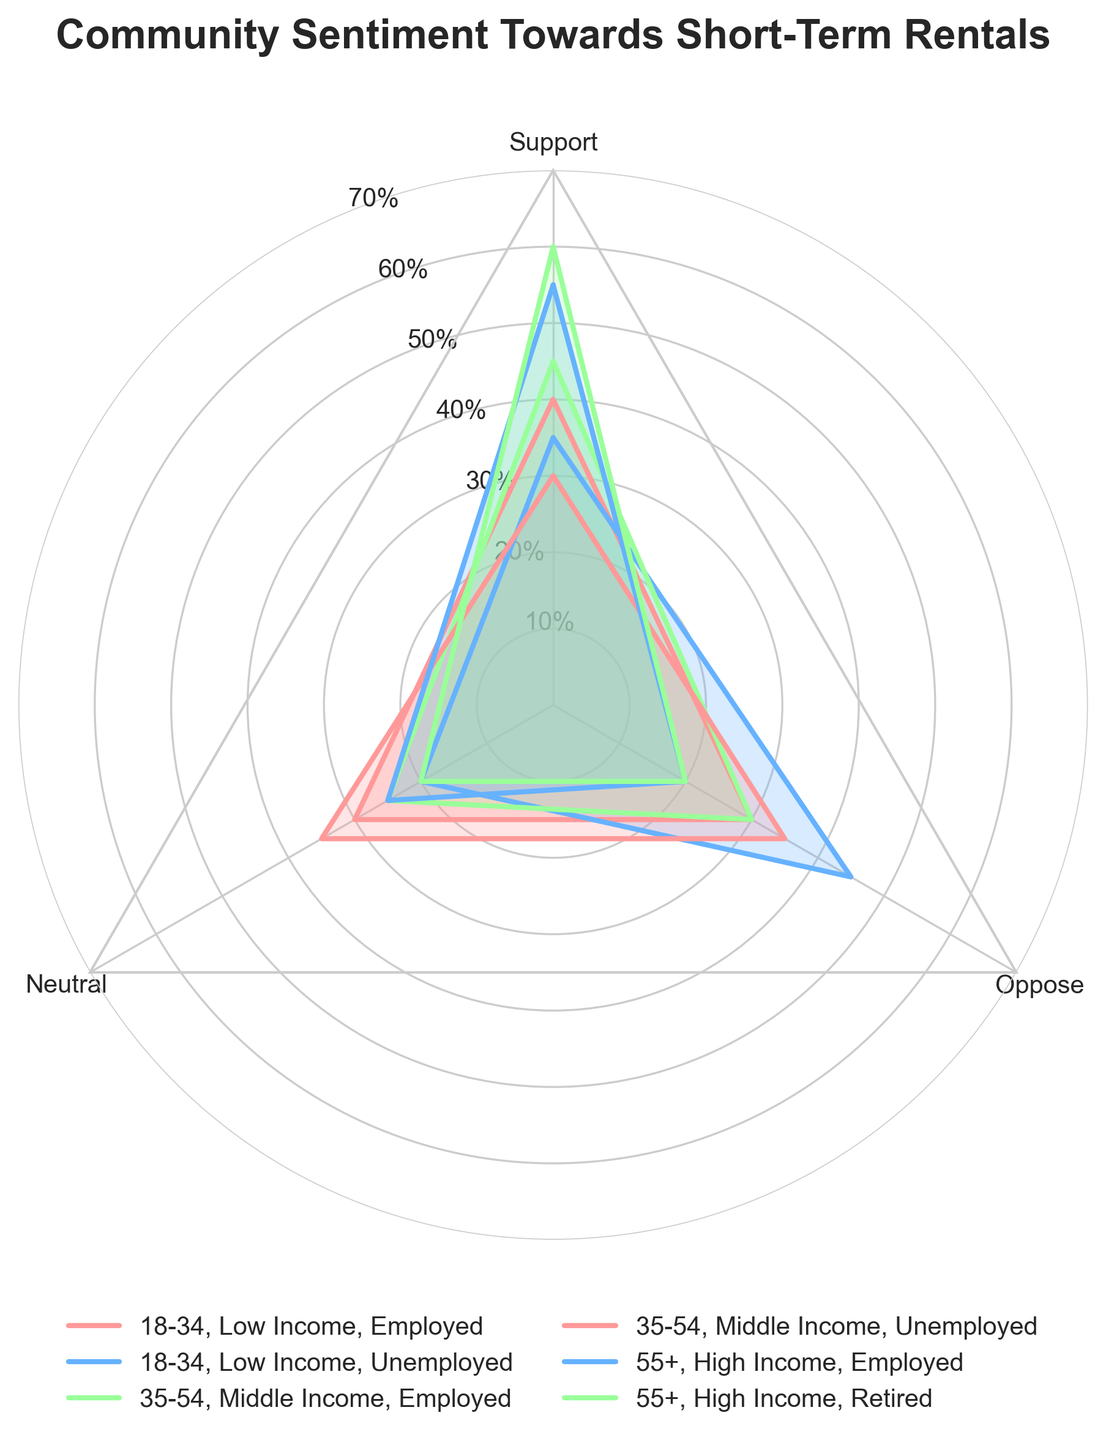What is the percentage of support for short-term rentals among the group aged 55+ with high income and retired? In the radar chart, locate the segment for the group aged 55+ with high income and retired and find the value corresponding to 'Support.'
Answer: 60% Which group has the highest opposition percentage? Compare the 'Oppose' values across all groups in the chart. The group with the highest value is aged 18-34 with low income and unemployed at 45%.
Answer: 18-34, Low Income, Unemployed What is the average percentage of support across all groups? Calculate the average of 'Support' values for all groups (40+35+45+30+55+60)/6.
Answer: 44.17% Between employed individuals in the 18-34 age group and the 35-54 age group, who shows more support? Compare the 'Support' values for employed individuals in the 18-34 age group (40%) and the 35-54 age group (45%).
Answer: 35-54, Middle Income, Employed For the 55+ high-income group, which category has the lowest percentage? Look at the 'Support,' 'Neutral,' and 'Oppose' values for the 55+ high-income group and identify the lowest percentage. It's tied between 'Neutral' and 'Oppose' at 20%.
Answer: Neutral and Oppose What is the total percentage of neutral sentiment among unemployed individuals in all age groups? Sum the 'Neutral' values for unemployed individuals: 20% (18-34) + 35% (35-54) = 55%.
Answer: 55% How does the level of opposition among employed 18-34 compare to employed 35-54? Compare the 'Oppose' values for employed individuals in the 18-34 age group (30%) and the 35-54 age group (30%).
Answer: Equal What is the difference in support percentage between the highest and lowest income brackets among employed individuals? Find the 'Support' values for employed individuals in the lowest income bracket (18-34, 40%) and highest income bracket (55+, 55%) and compute the difference: 55% - 40% = 15%.
Answer: 15% Which age group has the most evenly distributed sentiment towards short-term rentals? Look for the age group where 'Support,' 'Neutral,' and 'Oppose' values are closest to each other. The age group 35-54, middle income, unemployed (30-35-35) seems to have the most balance.
Answer: 35-54, Middle Income, Unemployed Which group has the highest combined percentage of support and neutral sentiment? Calculate the sum of 'Support' and 'Neutral' for each group and compare. Highest is 55+ high-income retired with 60% + 20% = 80%.
Answer: 55+, High Income, Retired 